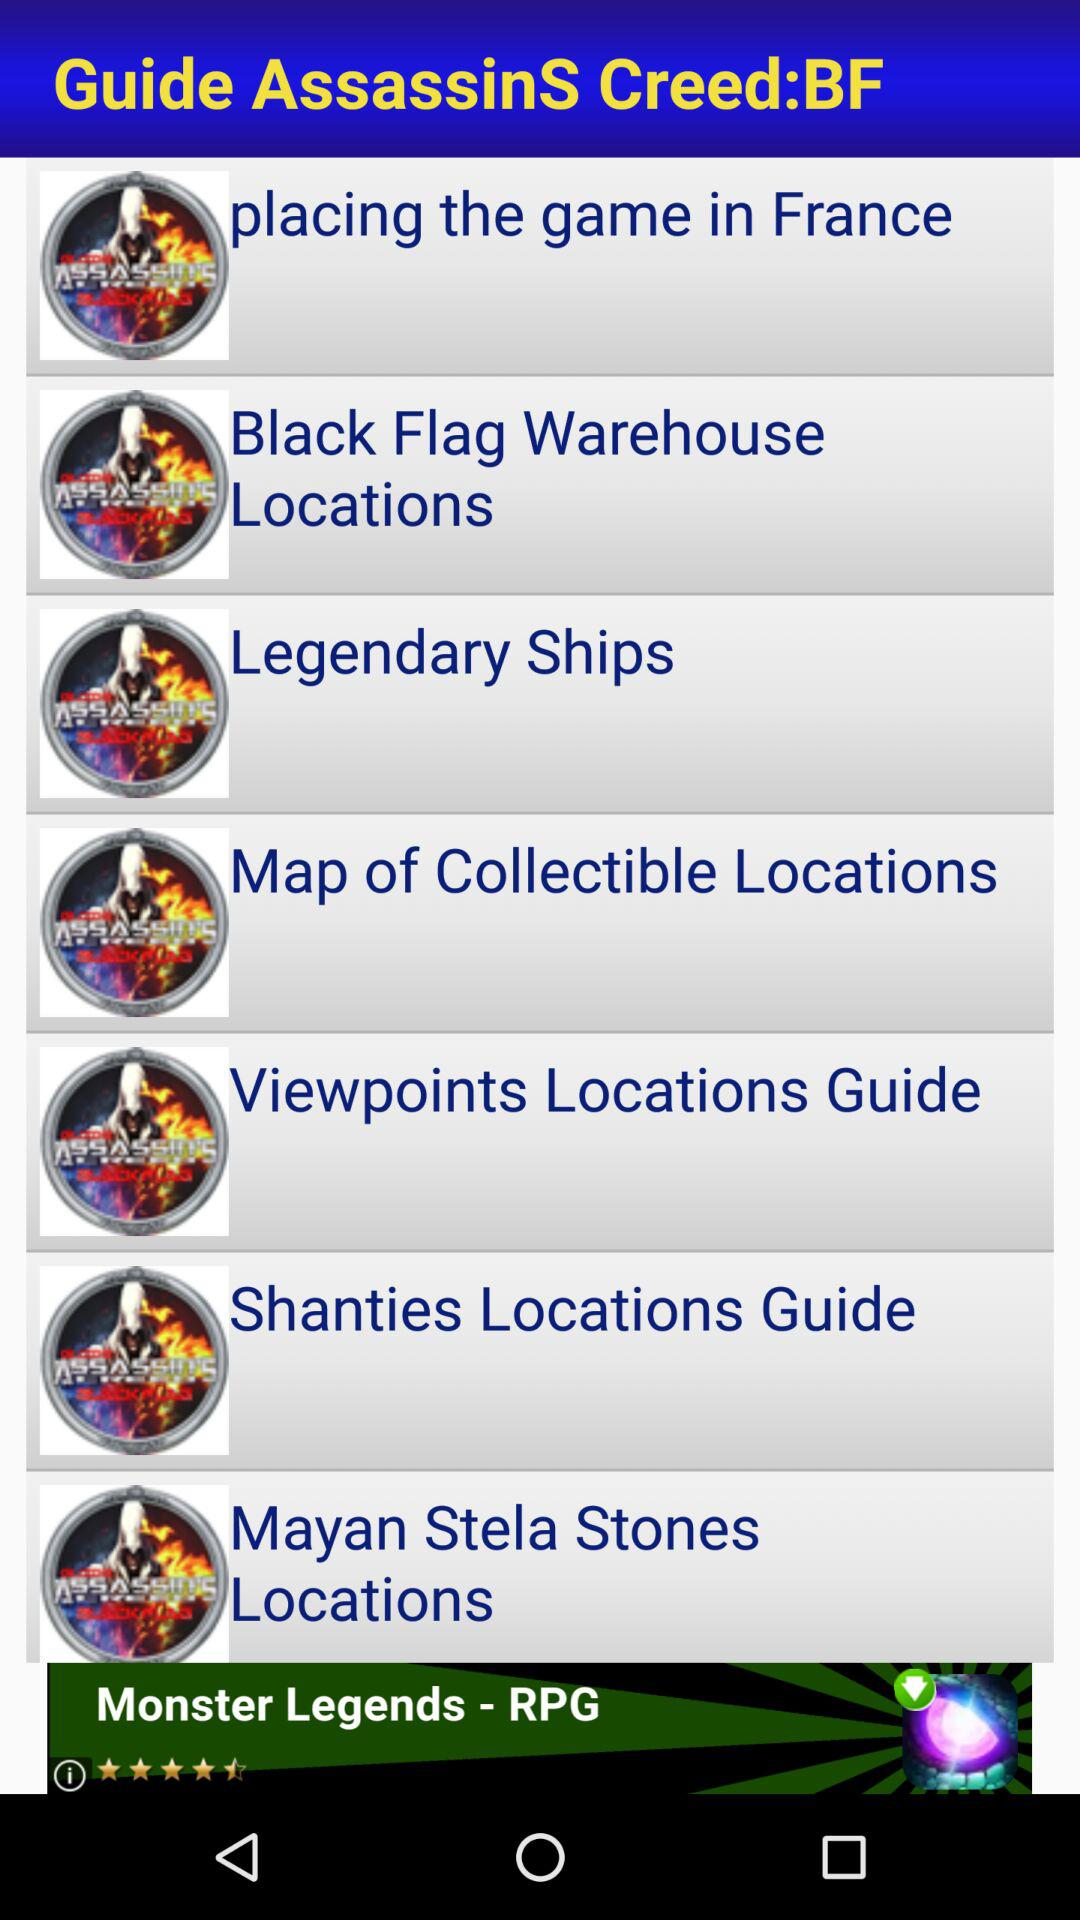Which are the different guides in "Guide AssassinsS Creed:BF"? The different guides in "Guide AssassinsS Creed:BF" are "placing the game in France", "Black Flag Warehouse Locations", "Black Flag Warehouse Locations", "Legendary Ships", "Map of Collectible Locations", "Viewpoints Locations Guide", "Shanties Locations Guide" and "Mayan Stela Stones Locations". 